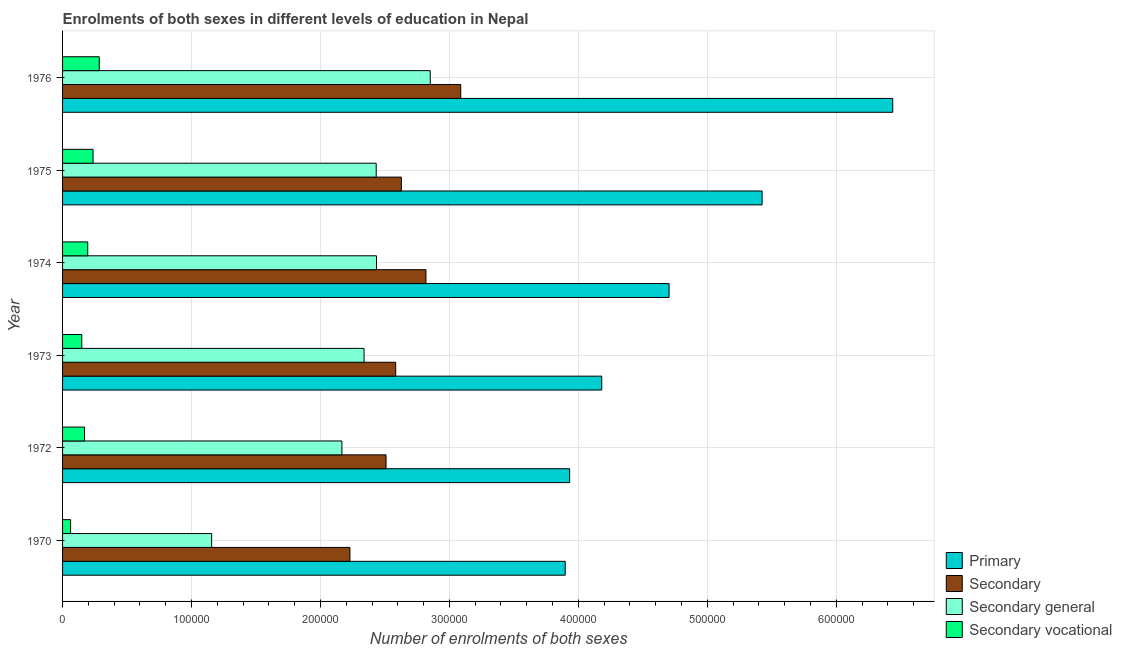How many groups of bars are there?
Your response must be concise. 6. How many bars are there on the 1st tick from the top?
Your answer should be very brief. 4. What is the label of the 3rd group of bars from the top?
Your answer should be compact. 1974. In how many cases, is the number of bars for a given year not equal to the number of legend labels?
Offer a terse response. 0. What is the number of enrolments in secondary general education in 1976?
Offer a terse response. 2.85e+05. Across all years, what is the maximum number of enrolments in primary education?
Give a very brief answer. 6.44e+05. Across all years, what is the minimum number of enrolments in secondary vocational education?
Keep it short and to the point. 6242. In which year was the number of enrolments in secondary general education maximum?
Provide a short and direct response. 1976. What is the total number of enrolments in primary education in the graph?
Give a very brief answer. 2.86e+06. What is the difference between the number of enrolments in secondary vocational education in 1970 and that in 1973?
Offer a very short reply. -8660. What is the difference between the number of enrolments in secondary vocational education in 1972 and the number of enrolments in primary education in 1976?
Your response must be concise. -6.27e+05. What is the average number of enrolments in secondary education per year?
Offer a very short reply. 2.64e+05. In the year 1970, what is the difference between the number of enrolments in secondary education and number of enrolments in secondary vocational education?
Ensure brevity in your answer.  2.17e+05. What is the ratio of the number of enrolments in primary education in 1972 to that in 1976?
Make the answer very short. 0.61. What is the difference between the highest and the second highest number of enrolments in secondary education?
Ensure brevity in your answer.  2.70e+04. What is the difference between the highest and the lowest number of enrolments in secondary education?
Offer a terse response. 8.59e+04. Is the sum of the number of enrolments in secondary general education in 1972 and 1974 greater than the maximum number of enrolments in secondary education across all years?
Offer a terse response. Yes. Is it the case that in every year, the sum of the number of enrolments in secondary vocational education and number of enrolments in secondary education is greater than the sum of number of enrolments in secondary general education and number of enrolments in primary education?
Provide a succinct answer. No. What does the 1st bar from the top in 1975 represents?
Make the answer very short. Secondary vocational. What does the 4th bar from the bottom in 1972 represents?
Make the answer very short. Secondary vocational. Is it the case that in every year, the sum of the number of enrolments in primary education and number of enrolments in secondary education is greater than the number of enrolments in secondary general education?
Provide a succinct answer. Yes. How many bars are there?
Make the answer very short. 24. Are the values on the major ticks of X-axis written in scientific E-notation?
Your answer should be compact. No. Does the graph contain any zero values?
Your answer should be very brief. No. Does the graph contain grids?
Your answer should be compact. Yes. How many legend labels are there?
Ensure brevity in your answer.  4. What is the title of the graph?
Offer a terse response. Enrolments of both sexes in different levels of education in Nepal. Does "Quality Certification" appear as one of the legend labels in the graph?
Your response must be concise. No. What is the label or title of the X-axis?
Give a very brief answer. Number of enrolments of both sexes. What is the label or title of the Y-axis?
Your answer should be compact. Year. What is the Number of enrolments of both sexes of Primary in 1970?
Make the answer very short. 3.90e+05. What is the Number of enrolments of both sexes of Secondary in 1970?
Keep it short and to the point. 2.23e+05. What is the Number of enrolments of both sexes of Secondary general in 1970?
Offer a very short reply. 1.16e+05. What is the Number of enrolments of both sexes of Secondary vocational in 1970?
Your response must be concise. 6242. What is the Number of enrolments of both sexes in Primary in 1972?
Give a very brief answer. 3.93e+05. What is the Number of enrolments of both sexes in Secondary in 1972?
Your answer should be very brief. 2.51e+05. What is the Number of enrolments of both sexes in Secondary general in 1972?
Provide a short and direct response. 2.17e+05. What is the Number of enrolments of both sexes of Secondary vocational in 1972?
Provide a short and direct response. 1.71e+04. What is the Number of enrolments of both sexes of Primary in 1973?
Ensure brevity in your answer.  4.18e+05. What is the Number of enrolments of both sexes of Secondary in 1973?
Your answer should be compact. 2.58e+05. What is the Number of enrolments of both sexes of Secondary general in 1973?
Offer a terse response. 2.34e+05. What is the Number of enrolments of both sexes in Secondary vocational in 1973?
Your response must be concise. 1.49e+04. What is the Number of enrolments of both sexes in Primary in 1974?
Give a very brief answer. 4.70e+05. What is the Number of enrolments of both sexes in Secondary in 1974?
Give a very brief answer. 2.82e+05. What is the Number of enrolments of both sexes of Secondary general in 1974?
Make the answer very short. 2.43e+05. What is the Number of enrolments of both sexes of Secondary vocational in 1974?
Make the answer very short. 1.95e+04. What is the Number of enrolments of both sexes in Primary in 1975?
Provide a succinct answer. 5.43e+05. What is the Number of enrolments of both sexes of Secondary in 1975?
Offer a terse response. 2.63e+05. What is the Number of enrolments of both sexes of Secondary general in 1975?
Ensure brevity in your answer.  2.43e+05. What is the Number of enrolments of both sexes of Secondary vocational in 1975?
Your answer should be very brief. 2.36e+04. What is the Number of enrolments of both sexes in Primary in 1976?
Provide a succinct answer. 6.44e+05. What is the Number of enrolments of both sexes in Secondary in 1976?
Keep it short and to the point. 3.09e+05. What is the Number of enrolments of both sexes in Secondary general in 1976?
Ensure brevity in your answer.  2.85e+05. What is the Number of enrolments of both sexes in Secondary vocational in 1976?
Offer a terse response. 2.85e+04. Across all years, what is the maximum Number of enrolments of both sexes of Primary?
Provide a short and direct response. 6.44e+05. Across all years, what is the maximum Number of enrolments of both sexes in Secondary?
Your answer should be very brief. 3.09e+05. Across all years, what is the maximum Number of enrolments of both sexes of Secondary general?
Give a very brief answer. 2.85e+05. Across all years, what is the maximum Number of enrolments of both sexes in Secondary vocational?
Offer a very short reply. 2.85e+04. Across all years, what is the minimum Number of enrolments of both sexes of Primary?
Keep it short and to the point. 3.90e+05. Across all years, what is the minimum Number of enrolments of both sexes of Secondary?
Ensure brevity in your answer.  2.23e+05. Across all years, what is the minimum Number of enrolments of both sexes of Secondary general?
Provide a short and direct response. 1.16e+05. Across all years, what is the minimum Number of enrolments of both sexes of Secondary vocational?
Ensure brevity in your answer.  6242. What is the total Number of enrolments of both sexes in Primary in the graph?
Ensure brevity in your answer.  2.86e+06. What is the total Number of enrolments of both sexes in Secondary in the graph?
Offer a very short reply. 1.59e+06. What is the total Number of enrolments of both sexes of Secondary general in the graph?
Give a very brief answer. 1.34e+06. What is the total Number of enrolments of both sexes of Secondary vocational in the graph?
Give a very brief answer. 1.10e+05. What is the difference between the Number of enrolments of both sexes in Primary in 1970 and that in 1972?
Make the answer very short. -3444. What is the difference between the Number of enrolments of both sexes in Secondary in 1970 and that in 1972?
Your response must be concise. -2.80e+04. What is the difference between the Number of enrolments of both sexes in Secondary general in 1970 and that in 1972?
Offer a terse response. -1.01e+05. What is the difference between the Number of enrolments of both sexes in Secondary vocational in 1970 and that in 1972?
Offer a very short reply. -1.08e+04. What is the difference between the Number of enrolments of both sexes in Primary in 1970 and that in 1973?
Provide a succinct answer. -2.83e+04. What is the difference between the Number of enrolments of both sexes of Secondary in 1970 and that in 1973?
Keep it short and to the point. -3.55e+04. What is the difference between the Number of enrolments of both sexes in Secondary general in 1970 and that in 1973?
Provide a short and direct response. -1.18e+05. What is the difference between the Number of enrolments of both sexes of Secondary vocational in 1970 and that in 1973?
Offer a terse response. -8660. What is the difference between the Number of enrolments of both sexes in Primary in 1970 and that in 1974?
Your answer should be compact. -8.05e+04. What is the difference between the Number of enrolments of both sexes in Secondary in 1970 and that in 1974?
Ensure brevity in your answer.  -5.89e+04. What is the difference between the Number of enrolments of both sexes of Secondary general in 1970 and that in 1974?
Offer a very short reply. -1.28e+05. What is the difference between the Number of enrolments of both sexes in Secondary vocational in 1970 and that in 1974?
Keep it short and to the point. -1.33e+04. What is the difference between the Number of enrolments of both sexes of Primary in 1970 and that in 1975?
Your response must be concise. -1.53e+05. What is the difference between the Number of enrolments of both sexes of Secondary in 1970 and that in 1975?
Give a very brief answer. -3.99e+04. What is the difference between the Number of enrolments of both sexes in Secondary general in 1970 and that in 1975?
Your response must be concise. -1.28e+05. What is the difference between the Number of enrolments of both sexes of Secondary vocational in 1970 and that in 1975?
Keep it short and to the point. -1.74e+04. What is the difference between the Number of enrolments of both sexes of Primary in 1970 and that in 1976?
Provide a succinct answer. -2.54e+05. What is the difference between the Number of enrolments of both sexes of Secondary in 1970 and that in 1976?
Your answer should be compact. -8.59e+04. What is the difference between the Number of enrolments of both sexes of Secondary general in 1970 and that in 1976?
Make the answer very short. -1.70e+05. What is the difference between the Number of enrolments of both sexes of Secondary vocational in 1970 and that in 1976?
Provide a short and direct response. -2.22e+04. What is the difference between the Number of enrolments of both sexes of Primary in 1972 and that in 1973?
Your response must be concise. -2.49e+04. What is the difference between the Number of enrolments of both sexes of Secondary in 1972 and that in 1973?
Offer a terse response. -7497. What is the difference between the Number of enrolments of both sexes in Secondary general in 1972 and that in 1973?
Provide a succinct answer. -1.72e+04. What is the difference between the Number of enrolments of both sexes in Secondary vocational in 1972 and that in 1973?
Your answer should be compact. 2149. What is the difference between the Number of enrolments of both sexes in Primary in 1972 and that in 1974?
Keep it short and to the point. -7.71e+04. What is the difference between the Number of enrolments of both sexes in Secondary in 1972 and that in 1974?
Your answer should be very brief. -3.09e+04. What is the difference between the Number of enrolments of both sexes in Secondary general in 1972 and that in 1974?
Offer a terse response. -2.68e+04. What is the difference between the Number of enrolments of both sexes of Secondary vocational in 1972 and that in 1974?
Keep it short and to the point. -2466. What is the difference between the Number of enrolments of both sexes in Primary in 1972 and that in 1975?
Give a very brief answer. -1.49e+05. What is the difference between the Number of enrolments of both sexes of Secondary in 1972 and that in 1975?
Provide a short and direct response. -1.19e+04. What is the difference between the Number of enrolments of both sexes in Secondary general in 1972 and that in 1975?
Give a very brief answer. -2.66e+04. What is the difference between the Number of enrolments of both sexes of Secondary vocational in 1972 and that in 1975?
Offer a terse response. -6592. What is the difference between the Number of enrolments of both sexes of Primary in 1972 and that in 1976?
Keep it short and to the point. -2.51e+05. What is the difference between the Number of enrolments of both sexes of Secondary in 1972 and that in 1976?
Provide a short and direct response. -5.79e+04. What is the difference between the Number of enrolments of both sexes of Secondary general in 1972 and that in 1976?
Make the answer very short. -6.85e+04. What is the difference between the Number of enrolments of both sexes of Secondary vocational in 1972 and that in 1976?
Your response must be concise. -1.14e+04. What is the difference between the Number of enrolments of both sexes of Primary in 1973 and that in 1974?
Offer a terse response. -5.22e+04. What is the difference between the Number of enrolments of both sexes in Secondary in 1973 and that in 1974?
Your response must be concise. -2.35e+04. What is the difference between the Number of enrolments of both sexes in Secondary general in 1973 and that in 1974?
Your answer should be very brief. -9646. What is the difference between the Number of enrolments of both sexes of Secondary vocational in 1973 and that in 1974?
Give a very brief answer. -4615. What is the difference between the Number of enrolments of both sexes of Primary in 1973 and that in 1975?
Make the answer very short. -1.24e+05. What is the difference between the Number of enrolments of both sexes of Secondary in 1973 and that in 1975?
Your answer should be compact. -4383. What is the difference between the Number of enrolments of both sexes of Secondary general in 1973 and that in 1975?
Make the answer very short. -9414. What is the difference between the Number of enrolments of both sexes of Secondary vocational in 1973 and that in 1975?
Offer a terse response. -8741. What is the difference between the Number of enrolments of both sexes in Primary in 1973 and that in 1976?
Give a very brief answer. -2.26e+05. What is the difference between the Number of enrolments of both sexes of Secondary in 1973 and that in 1976?
Provide a short and direct response. -5.04e+04. What is the difference between the Number of enrolments of both sexes of Secondary general in 1973 and that in 1976?
Make the answer very short. -5.13e+04. What is the difference between the Number of enrolments of both sexes in Secondary vocational in 1973 and that in 1976?
Your answer should be compact. -1.36e+04. What is the difference between the Number of enrolments of both sexes in Primary in 1974 and that in 1975?
Offer a terse response. -7.22e+04. What is the difference between the Number of enrolments of both sexes of Secondary in 1974 and that in 1975?
Give a very brief answer. 1.91e+04. What is the difference between the Number of enrolments of both sexes in Secondary general in 1974 and that in 1975?
Provide a short and direct response. 232. What is the difference between the Number of enrolments of both sexes of Secondary vocational in 1974 and that in 1975?
Offer a very short reply. -4126. What is the difference between the Number of enrolments of both sexes in Primary in 1974 and that in 1976?
Ensure brevity in your answer.  -1.73e+05. What is the difference between the Number of enrolments of both sexes of Secondary in 1974 and that in 1976?
Keep it short and to the point. -2.70e+04. What is the difference between the Number of enrolments of both sexes in Secondary general in 1974 and that in 1976?
Your answer should be compact. -4.17e+04. What is the difference between the Number of enrolments of both sexes in Secondary vocational in 1974 and that in 1976?
Ensure brevity in your answer.  -8945. What is the difference between the Number of enrolments of both sexes in Primary in 1975 and that in 1976?
Provide a succinct answer. -1.01e+05. What is the difference between the Number of enrolments of both sexes of Secondary in 1975 and that in 1976?
Offer a very short reply. -4.60e+04. What is the difference between the Number of enrolments of both sexes of Secondary general in 1975 and that in 1976?
Make the answer very short. -4.19e+04. What is the difference between the Number of enrolments of both sexes of Secondary vocational in 1975 and that in 1976?
Your answer should be very brief. -4819. What is the difference between the Number of enrolments of both sexes in Primary in 1970 and the Number of enrolments of both sexes in Secondary in 1972?
Ensure brevity in your answer.  1.39e+05. What is the difference between the Number of enrolments of both sexes in Primary in 1970 and the Number of enrolments of both sexes in Secondary general in 1972?
Provide a succinct answer. 1.73e+05. What is the difference between the Number of enrolments of both sexes in Primary in 1970 and the Number of enrolments of both sexes in Secondary vocational in 1972?
Your answer should be compact. 3.73e+05. What is the difference between the Number of enrolments of both sexes in Secondary in 1970 and the Number of enrolments of both sexes in Secondary general in 1972?
Provide a succinct answer. 6242. What is the difference between the Number of enrolments of both sexes of Secondary in 1970 and the Number of enrolments of both sexes of Secondary vocational in 1972?
Provide a succinct answer. 2.06e+05. What is the difference between the Number of enrolments of both sexes of Secondary general in 1970 and the Number of enrolments of both sexes of Secondary vocational in 1972?
Your answer should be very brief. 9.86e+04. What is the difference between the Number of enrolments of both sexes in Primary in 1970 and the Number of enrolments of both sexes in Secondary in 1973?
Keep it short and to the point. 1.31e+05. What is the difference between the Number of enrolments of both sexes in Primary in 1970 and the Number of enrolments of both sexes in Secondary general in 1973?
Make the answer very short. 1.56e+05. What is the difference between the Number of enrolments of both sexes of Primary in 1970 and the Number of enrolments of both sexes of Secondary vocational in 1973?
Make the answer very short. 3.75e+05. What is the difference between the Number of enrolments of both sexes of Secondary in 1970 and the Number of enrolments of both sexes of Secondary general in 1973?
Give a very brief answer. -1.10e+04. What is the difference between the Number of enrolments of both sexes of Secondary in 1970 and the Number of enrolments of both sexes of Secondary vocational in 1973?
Offer a very short reply. 2.08e+05. What is the difference between the Number of enrolments of both sexes in Secondary general in 1970 and the Number of enrolments of both sexes in Secondary vocational in 1973?
Your answer should be compact. 1.01e+05. What is the difference between the Number of enrolments of both sexes in Primary in 1970 and the Number of enrolments of both sexes in Secondary in 1974?
Your response must be concise. 1.08e+05. What is the difference between the Number of enrolments of both sexes of Primary in 1970 and the Number of enrolments of both sexes of Secondary general in 1974?
Make the answer very short. 1.46e+05. What is the difference between the Number of enrolments of both sexes of Primary in 1970 and the Number of enrolments of both sexes of Secondary vocational in 1974?
Offer a terse response. 3.70e+05. What is the difference between the Number of enrolments of both sexes in Secondary in 1970 and the Number of enrolments of both sexes in Secondary general in 1974?
Provide a succinct answer. -2.06e+04. What is the difference between the Number of enrolments of both sexes of Secondary in 1970 and the Number of enrolments of both sexes of Secondary vocational in 1974?
Your answer should be compact. 2.03e+05. What is the difference between the Number of enrolments of both sexes of Secondary general in 1970 and the Number of enrolments of both sexes of Secondary vocational in 1974?
Your response must be concise. 9.61e+04. What is the difference between the Number of enrolments of both sexes in Primary in 1970 and the Number of enrolments of both sexes in Secondary in 1975?
Your answer should be very brief. 1.27e+05. What is the difference between the Number of enrolments of both sexes in Primary in 1970 and the Number of enrolments of both sexes in Secondary general in 1975?
Make the answer very short. 1.47e+05. What is the difference between the Number of enrolments of both sexes of Primary in 1970 and the Number of enrolments of both sexes of Secondary vocational in 1975?
Provide a succinct answer. 3.66e+05. What is the difference between the Number of enrolments of both sexes in Secondary in 1970 and the Number of enrolments of both sexes in Secondary general in 1975?
Your answer should be compact. -2.04e+04. What is the difference between the Number of enrolments of both sexes of Secondary in 1970 and the Number of enrolments of both sexes of Secondary vocational in 1975?
Offer a terse response. 1.99e+05. What is the difference between the Number of enrolments of both sexes in Secondary general in 1970 and the Number of enrolments of both sexes in Secondary vocational in 1975?
Provide a short and direct response. 9.20e+04. What is the difference between the Number of enrolments of both sexes of Primary in 1970 and the Number of enrolments of both sexes of Secondary in 1976?
Ensure brevity in your answer.  8.10e+04. What is the difference between the Number of enrolments of both sexes in Primary in 1970 and the Number of enrolments of both sexes in Secondary general in 1976?
Keep it short and to the point. 1.05e+05. What is the difference between the Number of enrolments of both sexes in Primary in 1970 and the Number of enrolments of both sexes in Secondary vocational in 1976?
Ensure brevity in your answer.  3.61e+05. What is the difference between the Number of enrolments of both sexes in Secondary in 1970 and the Number of enrolments of both sexes in Secondary general in 1976?
Make the answer very short. -6.23e+04. What is the difference between the Number of enrolments of both sexes in Secondary in 1970 and the Number of enrolments of both sexes in Secondary vocational in 1976?
Make the answer very short. 1.94e+05. What is the difference between the Number of enrolments of both sexes in Secondary general in 1970 and the Number of enrolments of both sexes in Secondary vocational in 1976?
Provide a short and direct response. 8.72e+04. What is the difference between the Number of enrolments of both sexes of Primary in 1972 and the Number of enrolments of both sexes of Secondary in 1973?
Ensure brevity in your answer.  1.35e+05. What is the difference between the Number of enrolments of both sexes in Primary in 1972 and the Number of enrolments of both sexes in Secondary general in 1973?
Give a very brief answer. 1.59e+05. What is the difference between the Number of enrolments of both sexes in Primary in 1972 and the Number of enrolments of both sexes in Secondary vocational in 1973?
Your answer should be compact. 3.78e+05. What is the difference between the Number of enrolments of both sexes in Secondary in 1972 and the Number of enrolments of both sexes in Secondary general in 1973?
Ensure brevity in your answer.  1.71e+04. What is the difference between the Number of enrolments of both sexes of Secondary in 1972 and the Number of enrolments of both sexes of Secondary vocational in 1973?
Provide a succinct answer. 2.36e+05. What is the difference between the Number of enrolments of both sexes of Secondary general in 1972 and the Number of enrolments of both sexes of Secondary vocational in 1973?
Your response must be concise. 2.02e+05. What is the difference between the Number of enrolments of both sexes of Primary in 1972 and the Number of enrolments of both sexes of Secondary in 1974?
Give a very brief answer. 1.11e+05. What is the difference between the Number of enrolments of both sexes in Primary in 1972 and the Number of enrolments of both sexes in Secondary general in 1974?
Give a very brief answer. 1.50e+05. What is the difference between the Number of enrolments of both sexes of Primary in 1972 and the Number of enrolments of both sexes of Secondary vocational in 1974?
Ensure brevity in your answer.  3.74e+05. What is the difference between the Number of enrolments of both sexes of Secondary in 1972 and the Number of enrolments of both sexes of Secondary general in 1974?
Ensure brevity in your answer.  7405. What is the difference between the Number of enrolments of both sexes of Secondary in 1972 and the Number of enrolments of both sexes of Secondary vocational in 1974?
Offer a terse response. 2.31e+05. What is the difference between the Number of enrolments of both sexes of Secondary general in 1972 and the Number of enrolments of both sexes of Secondary vocational in 1974?
Your answer should be compact. 1.97e+05. What is the difference between the Number of enrolments of both sexes of Primary in 1972 and the Number of enrolments of both sexes of Secondary in 1975?
Provide a short and direct response. 1.31e+05. What is the difference between the Number of enrolments of both sexes of Primary in 1972 and the Number of enrolments of both sexes of Secondary general in 1975?
Your response must be concise. 1.50e+05. What is the difference between the Number of enrolments of both sexes in Primary in 1972 and the Number of enrolments of both sexes in Secondary vocational in 1975?
Make the answer very short. 3.70e+05. What is the difference between the Number of enrolments of both sexes of Secondary in 1972 and the Number of enrolments of both sexes of Secondary general in 1975?
Offer a terse response. 7637. What is the difference between the Number of enrolments of both sexes of Secondary in 1972 and the Number of enrolments of both sexes of Secondary vocational in 1975?
Provide a short and direct response. 2.27e+05. What is the difference between the Number of enrolments of both sexes in Secondary general in 1972 and the Number of enrolments of both sexes in Secondary vocational in 1975?
Give a very brief answer. 1.93e+05. What is the difference between the Number of enrolments of both sexes in Primary in 1972 and the Number of enrolments of both sexes in Secondary in 1976?
Keep it short and to the point. 8.45e+04. What is the difference between the Number of enrolments of both sexes of Primary in 1972 and the Number of enrolments of both sexes of Secondary general in 1976?
Your answer should be compact. 1.08e+05. What is the difference between the Number of enrolments of both sexes in Primary in 1972 and the Number of enrolments of both sexes in Secondary vocational in 1976?
Offer a terse response. 3.65e+05. What is the difference between the Number of enrolments of both sexes in Secondary in 1972 and the Number of enrolments of both sexes in Secondary general in 1976?
Offer a very short reply. -3.43e+04. What is the difference between the Number of enrolments of both sexes in Secondary in 1972 and the Number of enrolments of both sexes in Secondary vocational in 1976?
Your response must be concise. 2.22e+05. What is the difference between the Number of enrolments of both sexes in Secondary general in 1972 and the Number of enrolments of both sexes in Secondary vocational in 1976?
Ensure brevity in your answer.  1.88e+05. What is the difference between the Number of enrolments of both sexes in Primary in 1973 and the Number of enrolments of both sexes in Secondary in 1974?
Give a very brief answer. 1.36e+05. What is the difference between the Number of enrolments of both sexes in Primary in 1973 and the Number of enrolments of both sexes in Secondary general in 1974?
Provide a short and direct response. 1.75e+05. What is the difference between the Number of enrolments of both sexes in Primary in 1973 and the Number of enrolments of both sexes in Secondary vocational in 1974?
Your response must be concise. 3.99e+05. What is the difference between the Number of enrolments of both sexes of Secondary in 1973 and the Number of enrolments of both sexes of Secondary general in 1974?
Offer a very short reply. 1.49e+04. What is the difference between the Number of enrolments of both sexes of Secondary in 1973 and the Number of enrolments of both sexes of Secondary vocational in 1974?
Your response must be concise. 2.39e+05. What is the difference between the Number of enrolments of both sexes of Secondary general in 1973 and the Number of enrolments of both sexes of Secondary vocational in 1974?
Your response must be concise. 2.14e+05. What is the difference between the Number of enrolments of both sexes of Primary in 1973 and the Number of enrolments of both sexes of Secondary in 1975?
Make the answer very short. 1.55e+05. What is the difference between the Number of enrolments of both sexes in Primary in 1973 and the Number of enrolments of both sexes in Secondary general in 1975?
Offer a terse response. 1.75e+05. What is the difference between the Number of enrolments of both sexes of Primary in 1973 and the Number of enrolments of both sexes of Secondary vocational in 1975?
Your answer should be very brief. 3.95e+05. What is the difference between the Number of enrolments of both sexes of Secondary in 1973 and the Number of enrolments of both sexes of Secondary general in 1975?
Your answer should be very brief. 1.51e+04. What is the difference between the Number of enrolments of both sexes of Secondary in 1973 and the Number of enrolments of both sexes of Secondary vocational in 1975?
Offer a terse response. 2.35e+05. What is the difference between the Number of enrolments of both sexes of Secondary general in 1973 and the Number of enrolments of both sexes of Secondary vocational in 1975?
Provide a succinct answer. 2.10e+05. What is the difference between the Number of enrolments of both sexes in Primary in 1973 and the Number of enrolments of both sexes in Secondary in 1976?
Your response must be concise. 1.09e+05. What is the difference between the Number of enrolments of both sexes in Primary in 1973 and the Number of enrolments of both sexes in Secondary general in 1976?
Your answer should be very brief. 1.33e+05. What is the difference between the Number of enrolments of both sexes of Primary in 1973 and the Number of enrolments of both sexes of Secondary vocational in 1976?
Ensure brevity in your answer.  3.90e+05. What is the difference between the Number of enrolments of both sexes of Secondary in 1973 and the Number of enrolments of both sexes of Secondary general in 1976?
Offer a terse response. -2.68e+04. What is the difference between the Number of enrolments of both sexes in Secondary in 1973 and the Number of enrolments of both sexes in Secondary vocational in 1976?
Provide a short and direct response. 2.30e+05. What is the difference between the Number of enrolments of both sexes in Secondary general in 1973 and the Number of enrolments of both sexes in Secondary vocational in 1976?
Your answer should be compact. 2.05e+05. What is the difference between the Number of enrolments of both sexes in Primary in 1974 and the Number of enrolments of both sexes in Secondary in 1975?
Make the answer very short. 2.08e+05. What is the difference between the Number of enrolments of both sexes in Primary in 1974 and the Number of enrolments of both sexes in Secondary general in 1975?
Your response must be concise. 2.27e+05. What is the difference between the Number of enrolments of both sexes in Primary in 1974 and the Number of enrolments of both sexes in Secondary vocational in 1975?
Your answer should be compact. 4.47e+05. What is the difference between the Number of enrolments of both sexes of Secondary in 1974 and the Number of enrolments of both sexes of Secondary general in 1975?
Make the answer very short. 3.86e+04. What is the difference between the Number of enrolments of both sexes in Secondary in 1974 and the Number of enrolments of both sexes in Secondary vocational in 1975?
Provide a short and direct response. 2.58e+05. What is the difference between the Number of enrolments of both sexes of Secondary general in 1974 and the Number of enrolments of both sexes of Secondary vocational in 1975?
Give a very brief answer. 2.20e+05. What is the difference between the Number of enrolments of both sexes in Primary in 1974 and the Number of enrolments of both sexes in Secondary in 1976?
Offer a very short reply. 1.62e+05. What is the difference between the Number of enrolments of both sexes in Primary in 1974 and the Number of enrolments of both sexes in Secondary general in 1976?
Provide a short and direct response. 1.85e+05. What is the difference between the Number of enrolments of both sexes of Primary in 1974 and the Number of enrolments of both sexes of Secondary vocational in 1976?
Provide a short and direct response. 4.42e+05. What is the difference between the Number of enrolments of both sexes in Secondary in 1974 and the Number of enrolments of both sexes in Secondary general in 1976?
Make the answer very short. -3338. What is the difference between the Number of enrolments of both sexes of Secondary in 1974 and the Number of enrolments of both sexes of Secondary vocational in 1976?
Make the answer very short. 2.53e+05. What is the difference between the Number of enrolments of both sexes of Secondary general in 1974 and the Number of enrolments of both sexes of Secondary vocational in 1976?
Give a very brief answer. 2.15e+05. What is the difference between the Number of enrolments of both sexes in Primary in 1975 and the Number of enrolments of both sexes in Secondary in 1976?
Keep it short and to the point. 2.34e+05. What is the difference between the Number of enrolments of both sexes of Primary in 1975 and the Number of enrolments of both sexes of Secondary general in 1976?
Offer a terse response. 2.57e+05. What is the difference between the Number of enrolments of both sexes of Primary in 1975 and the Number of enrolments of both sexes of Secondary vocational in 1976?
Your answer should be very brief. 5.14e+05. What is the difference between the Number of enrolments of both sexes of Secondary in 1975 and the Number of enrolments of both sexes of Secondary general in 1976?
Keep it short and to the point. -2.24e+04. What is the difference between the Number of enrolments of both sexes of Secondary in 1975 and the Number of enrolments of both sexes of Secondary vocational in 1976?
Your response must be concise. 2.34e+05. What is the difference between the Number of enrolments of both sexes of Secondary general in 1975 and the Number of enrolments of both sexes of Secondary vocational in 1976?
Your answer should be very brief. 2.15e+05. What is the average Number of enrolments of both sexes in Primary per year?
Make the answer very short. 4.76e+05. What is the average Number of enrolments of both sexes in Secondary per year?
Make the answer very short. 2.64e+05. What is the average Number of enrolments of both sexes of Secondary general per year?
Offer a terse response. 2.23e+05. What is the average Number of enrolments of both sexes of Secondary vocational per year?
Provide a succinct answer. 1.83e+04. In the year 1970, what is the difference between the Number of enrolments of both sexes of Primary and Number of enrolments of both sexes of Secondary?
Offer a very short reply. 1.67e+05. In the year 1970, what is the difference between the Number of enrolments of both sexes in Primary and Number of enrolments of both sexes in Secondary general?
Your response must be concise. 2.74e+05. In the year 1970, what is the difference between the Number of enrolments of both sexes in Primary and Number of enrolments of both sexes in Secondary vocational?
Your response must be concise. 3.84e+05. In the year 1970, what is the difference between the Number of enrolments of both sexes in Secondary and Number of enrolments of both sexes in Secondary general?
Ensure brevity in your answer.  1.07e+05. In the year 1970, what is the difference between the Number of enrolments of both sexes of Secondary and Number of enrolments of both sexes of Secondary vocational?
Make the answer very short. 2.17e+05. In the year 1970, what is the difference between the Number of enrolments of both sexes in Secondary general and Number of enrolments of both sexes in Secondary vocational?
Your answer should be compact. 1.09e+05. In the year 1972, what is the difference between the Number of enrolments of both sexes of Primary and Number of enrolments of both sexes of Secondary?
Your response must be concise. 1.42e+05. In the year 1972, what is the difference between the Number of enrolments of both sexes of Primary and Number of enrolments of both sexes of Secondary general?
Your response must be concise. 1.77e+05. In the year 1972, what is the difference between the Number of enrolments of both sexes in Primary and Number of enrolments of both sexes in Secondary vocational?
Offer a very short reply. 3.76e+05. In the year 1972, what is the difference between the Number of enrolments of both sexes of Secondary and Number of enrolments of both sexes of Secondary general?
Your answer should be very brief. 3.42e+04. In the year 1972, what is the difference between the Number of enrolments of both sexes in Secondary and Number of enrolments of both sexes in Secondary vocational?
Your response must be concise. 2.34e+05. In the year 1972, what is the difference between the Number of enrolments of both sexes of Secondary general and Number of enrolments of both sexes of Secondary vocational?
Make the answer very short. 2.00e+05. In the year 1973, what is the difference between the Number of enrolments of both sexes in Primary and Number of enrolments of both sexes in Secondary?
Your answer should be compact. 1.60e+05. In the year 1973, what is the difference between the Number of enrolments of both sexes in Primary and Number of enrolments of both sexes in Secondary general?
Offer a terse response. 1.84e+05. In the year 1973, what is the difference between the Number of enrolments of both sexes in Primary and Number of enrolments of both sexes in Secondary vocational?
Ensure brevity in your answer.  4.03e+05. In the year 1973, what is the difference between the Number of enrolments of both sexes of Secondary and Number of enrolments of both sexes of Secondary general?
Keep it short and to the point. 2.45e+04. In the year 1973, what is the difference between the Number of enrolments of both sexes in Secondary and Number of enrolments of both sexes in Secondary vocational?
Your answer should be very brief. 2.43e+05. In the year 1973, what is the difference between the Number of enrolments of both sexes in Secondary general and Number of enrolments of both sexes in Secondary vocational?
Offer a terse response. 2.19e+05. In the year 1974, what is the difference between the Number of enrolments of both sexes of Primary and Number of enrolments of both sexes of Secondary?
Offer a terse response. 1.89e+05. In the year 1974, what is the difference between the Number of enrolments of both sexes of Primary and Number of enrolments of both sexes of Secondary general?
Provide a succinct answer. 2.27e+05. In the year 1974, what is the difference between the Number of enrolments of both sexes in Primary and Number of enrolments of both sexes in Secondary vocational?
Give a very brief answer. 4.51e+05. In the year 1974, what is the difference between the Number of enrolments of both sexes of Secondary and Number of enrolments of both sexes of Secondary general?
Keep it short and to the point. 3.84e+04. In the year 1974, what is the difference between the Number of enrolments of both sexes in Secondary and Number of enrolments of both sexes in Secondary vocational?
Keep it short and to the point. 2.62e+05. In the year 1974, what is the difference between the Number of enrolments of both sexes in Secondary general and Number of enrolments of both sexes in Secondary vocational?
Your response must be concise. 2.24e+05. In the year 1975, what is the difference between the Number of enrolments of both sexes of Primary and Number of enrolments of both sexes of Secondary?
Your answer should be very brief. 2.80e+05. In the year 1975, what is the difference between the Number of enrolments of both sexes in Primary and Number of enrolments of both sexes in Secondary general?
Offer a terse response. 2.99e+05. In the year 1975, what is the difference between the Number of enrolments of both sexes in Primary and Number of enrolments of both sexes in Secondary vocational?
Keep it short and to the point. 5.19e+05. In the year 1975, what is the difference between the Number of enrolments of both sexes of Secondary and Number of enrolments of both sexes of Secondary general?
Your answer should be very brief. 1.95e+04. In the year 1975, what is the difference between the Number of enrolments of both sexes of Secondary and Number of enrolments of both sexes of Secondary vocational?
Ensure brevity in your answer.  2.39e+05. In the year 1975, what is the difference between the Number of enrolments of both sexes in Secondary general and Number of enrolments of both sexes in Secondary vocational?
Provide a succinct answer. 2.20e+05. In the year 1976, what is the difference between the Number of enrolments of both sexes of Primary and Number of enrolments of both sexes of Secondary?
Keep it short and to the point. 3.35e+05. In the year 1976, what is the difference between the Number of enrolments of both sexes in Primary and Number of enrolments of both sexes in Secondary general?
Your answer should be compact. 3.59e+05. In the year 1976, what is the difference between the Number of enrolments of both sexes in Primary and Number of enrolments of both sexes in Secondary vocational?
Your response must be concise. 6.15e+05. In the year 1976, what is the difference between the Number of enrolments of both sexes in Secondary and Number of enrolments of both sexes in Secondary general?
Give a very brief answer. 2.36e+04. In the year 1976, what is the difference between the Number of enrolments of both sexes of Secondary and Number of enrolments of both sexes of Secondary vocational?
Offer a terse response. 2.80e+05. In the year 1976, what is the difference between the Number of enrolments of both sexes of Secondary general and Number of enrolments of both sexes of Secondary vocational?
Give a very brief answer. 2.57e+05. What is the ratio of the Number of enrolments of both sexes in Secondary in 1970 to that in 1972?
Offer a terse response. 0.89. What is the ratio of the Number of enrolments of both sexes of Secondary general in 1970 to that in 1972?
Keep it short and to the point. 0.53. What is the ratio of the Number of enrolments of both sexes of Secondary vocational in 1970 to that in 1972?
Offer a terse response. 0.37. What is the ratio of the Number of enrolments of both sexes in Primary in 1970 to that in 1973?
Your answer should be very brief. 0.93. What is the ratio of the Number of enrolments of both sexes in Secondary in 1970 to that in 1973?
Keep it short and to the point. 0.86. What is the ratio of the Number of enrolments of both sexes of Secondary general in 1970 to that in 1973?
Your response must be concise. 0.49. What is the ratio of the Number of enrolments of both sexes in Secondary vocational in 1970 to that in 1973?
Offer a very short reply. 0.42. What is the ratio of the Number of enrolments of both sexes in Primary in 1970 to that in 1974?
Your answer should be very brief. 0.83. What is the ratio of the Number of enrolments of both sexes in Secondary in 1970 to that in 1974?
Offer a terse response. 0.79. What is the ratio of the Number of enrolments of both sexes of Secondary general in 1970 to that in 1974?
Offer a terse response. 0.47. What is the ratio of the Number of enrolments of both sexes in Secondary vocational in 1970 to that in 1974?
Ensure brevity in your answer.  0.32. What is the ratio of the Number of enrolments of both sexes of Primary in 1970 to that in 1975?
Make the answer very short. 0.72. What is the ratio of the Number of enrolments of both sexes in Secondary in 1970 to that in 1975?
Provide a succinct answer. 0.85. What is the ratio of the Number of enrolments of both sexes of Secondary general in 1970 to that in 1975?
Your response must be concise. 0.48. What is the ratio of the Number of enrolments of both sexes of Secondary vocational in 1970 to that in 1975?
Offer a terse response. 0.26. What is the ratio of the Number of enrolments of both sexes of Primary in 1970 to that in 1976?
Offer a very short reply. 0.61. What is the ratio of the Number of enrolments of both sexes in Secondary in 1970 to that in 1976?
Offer a terse response. 0.72. What is the ratio of the Number of enrolments of both sexes of Secondary general in 1970 to that in 1976?
Provide a short and direct response. 0.41. What is the ratio of the Number of enrolments of both sexes of Secondary vocational in 1970 to that in 1976?
Offer a very short reply. 0.22. What is the ratio of the Number of enrolments of both sexes of Primary in 1972 to that in 1973?
Offer a terse response. 0.94. What is the ratio of the Number of enrolments of both sexes of Secondary general in 1972 to that in 1973?
Provide a short and direct response. 0.93. What is the ratio of the Number of enrolments of both sexes in Secondary vocational in 1972 to that in 1973?
Your answer should be compact. 1.14. What is the ratio of the Number of enrolments of both sexes of Primary in 1972 to that in 1974?
Your answer should be very brief. 0.84. What is the ratio of the Number of enrolments of both sexes in Secondary in 1972 to that in 1974?
Ensure brevity in your answer.  0.89. What is the ratio of the Number of enrolments of both sexes in Secondary general in 1972 to that in 1974?
Make the answer very short. 0.89. What is the ratio of the Number of enrolments of both sexes in Secondary vocational in 1972 to that in 1974?
Ensure brevity in your answer.  0.87. What is the ratio of the Number of enrolments of both sexes in Primary in 1972 to that in 1975?
Your answer should be compact. 0.72. What is the ratio of the Number of enrolments of both sexes in Secondary in 1972 to that in 1975?
Give a very brief answer. 0.95. What is the ratio of the Number of enrolments of both sexes of Secondary general in 1972 to that in 1975?
Offer a very short reply. 0.89. What is the ratio of the Number of enrolments of both sexes of Secondary vocational in 1972 to that in 1975?
Your answer should be very brief. 0.72. What is the ratio of the Number of enrolments of both sexes of Primary in 1972 to that in 1976?
Offer a terse response. 0.61. What is the ratio of the Number of enrolments of both sexes of Secondary in 1972 to that in 1976?
Offer a very short reply. 0.81. What is the ratio of the Number of enrolments of both sexes of Secondary general in 1972 to that in 1976?
Provide a short and direct response. 0.76. What is the ratio of the Number of enrolments of both sexes in Secondary vocational in 1972 to that in 1976?
Your response must be concise. 0.6. What is the ratio of the Number of enrolments of both sexes of Primary in 1973 to that in 1974?
Give a very brief answer. 0.89. What is the ratio of the Number of enrolments of both sexes of Secondary in 1973 to that in 1974?
Your answer should be very brief. 0.92. What is the ratio of the Number of enrolments of both sexes in Secondary general in 1973 to that in 1974?
Ensure brevity in your answer.  0.96. What is the ratio of the Number of enrolments of both sexes of Secondary vocational in 1973 to that in 1974?
Provide a succinct answer. 0.76. What is the ratio of the Number of enrolments of both sexes in Primary in 1973 to that in 1975?
Make the answer very short. 0.77. What is the ratio of the Number of enrolments of both sexes in Secondary in 1973 to that in 1975?
Offer a terse response. 0.98. What is the ratio of the Number of enrolments of both sexes of Secondary general in 1973 to that in 1975?
Ensure brevity in your answer.  0.96. What is the ratio of the Number of enrolments of both sexes in Secondary vocational in 1973 to that in 1975?
Offer a terse response. 0.63. What is the ratio of the Number of enrolments of both sexes of Primary in 1973 to that in 1976?
Provide a succinct answer. 0.65. What is the ratio of the Number of enrolments of both sexes in Secondary in 1973 to that in 1976?
Give a very brief answer. 0.84. What is the ratio of the Number of enrolments of both sexes of Secondary general in 1973 to that in 1976?
Provide a short and direct response. 0.82. What is the ratio of the Number of enrolments of both sexes of Secondary vocational in 1973 to that in 1976?
Provide a short and direct response. 0.52. What is the ratio of the Number of enrolments of both sexes in Primary in 1974 to that in 1975?
Keep it short and to the point. 0.87. What is the ratio of the Number of enrolments of both sexes of Secondary in 1974 to that in 1975?
Provide a short and direct response. 1.07. What is the ratio of the Number of enrolments of both sexes in Secondary general in 1974 to that in 1975?
Ensure brevity in your answer.  1. What is the ratio of the Number of enrolments of both sexes of Secondary vocational in 1974 to that in 1975?
Keep it short and to the point. 0.83. What is the ratio of the Number of enrolments of both sexes of Primary in 1974 to that in 1976?
Keep it short and to the point. 0.73. What is the ratio of the Number of enrolments of both sexes of Secondary in 1974 to that in 1976?
Provide a short and direct response. 0.91. What is the ratio of the Number of enrolments of both sexes of Secondary general in 1974 to that in 1976?
Give a very brief answer. 0.85. What is the ratio of the Number of enrolments of both sexes of Secondary vocational in 1974 to that in 1976?
Provide a succinct answer. 0.69. What is the ratio of the Number of enrolments of both sexes of Primary in 1975 to that in 1976?
Offer a terse response. 0.84. What is the ratio of the Number of enrolments of both sexes in Secondary in 1975 to that in 1976?
Your response must be concise. 0.85. What is the ratio of the Number of enrolments of both sexes in Secondary general in 1975 to that in 1976?
Make the answer very short. 0.85. What is the ratio of the Number of enrolments of both sexes of Secondary vocational in 1975 to that in 1976?
Provide a succinct answer. 0.83. What is the difference between the highest and the second highest Number of enrolments of both sexes of Primary?
Ensure brevity in your answer.  1.01e+05. What is the difference between the highest and the second highest Number of enrolments of both sexes of Secondary?
Your answer should be very brief. 2.70e+04. What is the difference between the highest and the second highest Number of enrolments of both sexes of Secondary general?
Provide a short and direct response. 4.17e+04. What is the difference between the highest and the second highest Number of enrolments of both sexes in Secondary vocational?
Your answer should be compact. 4819. What is the difference between the highest and the lowest Number of enrolments of both sexes of Primary?
Ensure brevity in your answer.  2.54e+05. What is the difference between the highest and the lowest Number of enrolments of both sexes in Secondary?
Ensure brevity in your answer.  8.59e+04. What is the difference between the highest and the lowest Number of enrolments of both sexes in Secondary general?
Provide a succinct answer. 1.70e+05. What is the difference between the highest and the lowest Number of enrolments of both sexes of Secondary vocational?
Provide a succinct answer. 2.22e+04. 